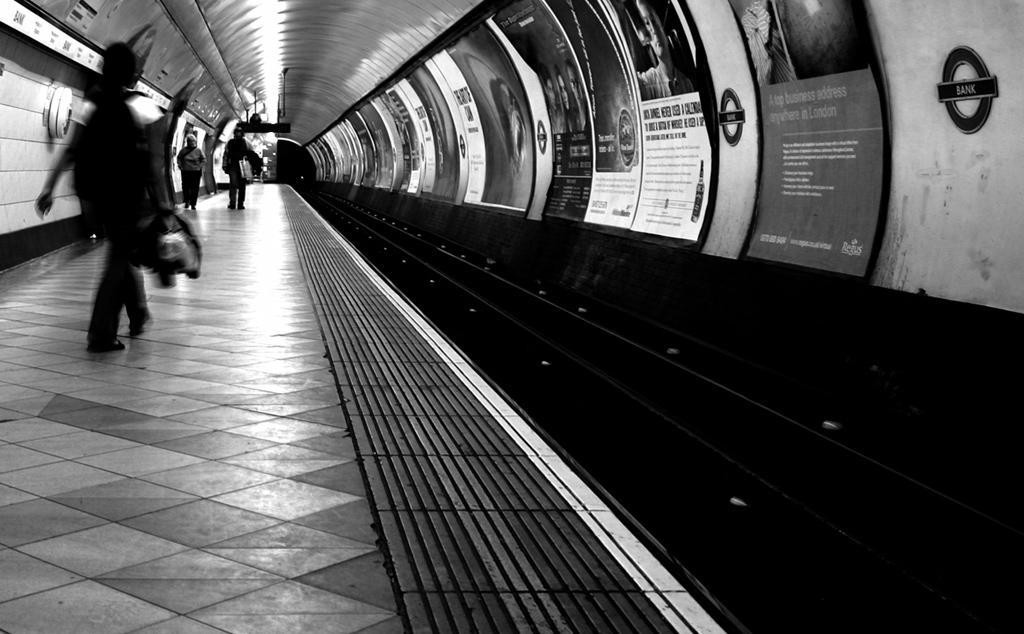Describe this image in one or two sentences. In this black and white picture there are a few people walking on the floor. To the right there are posters sticked on the wall. 